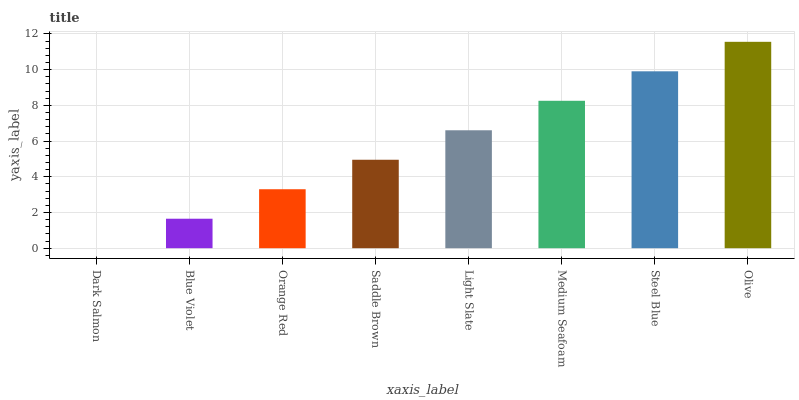Is Blue Violet the minimum?
Answer yes or no. No. Is Blue Violet the maximum?
Answer yes or no. No. Is Blue Violet greater than Dark Salmon?
Answer yes or no. Yes. Is Dark Salmon less than Blue Violet?
Answer yes or no. Yes. Is Dark Salmon greater than Blue Violet?
Answer yes or no. No. Is Blue Violet less than Dark Salmon?
Answer yes or no. No. Is Light Slate the high median?
Answer yes or no. Yes. Is Saddle Brown the low median?
Answer yes or no. Yes. Is Medium Seafoam the high median?
Answer yes or no. No. Is Medium Seafoam the low median?
Answer yes or no. No. 